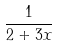<formula> <loc_0><loc_0><loc_500><loc_500>\frac { 1 } { 2 + 3 x }</formula> 